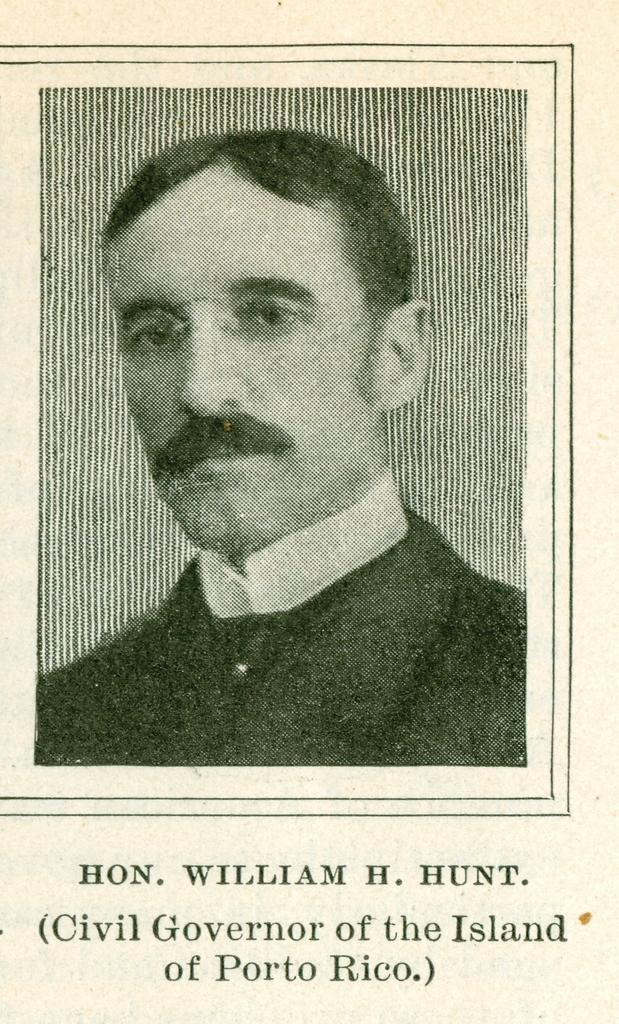What type of image is depicted in the picture? The image contains a black and white picture of a person. Can you describe any additional elements in the image? There is text at the bottom of the image. How much sugar is present in the image? There is no sugar present in the image; it contains a black and white picture of a person and text at the bottom. What type of meeting is taking place in the image? There is no meeting depicted in the image; it contains a black and white picture of a person and text at the bottom. 